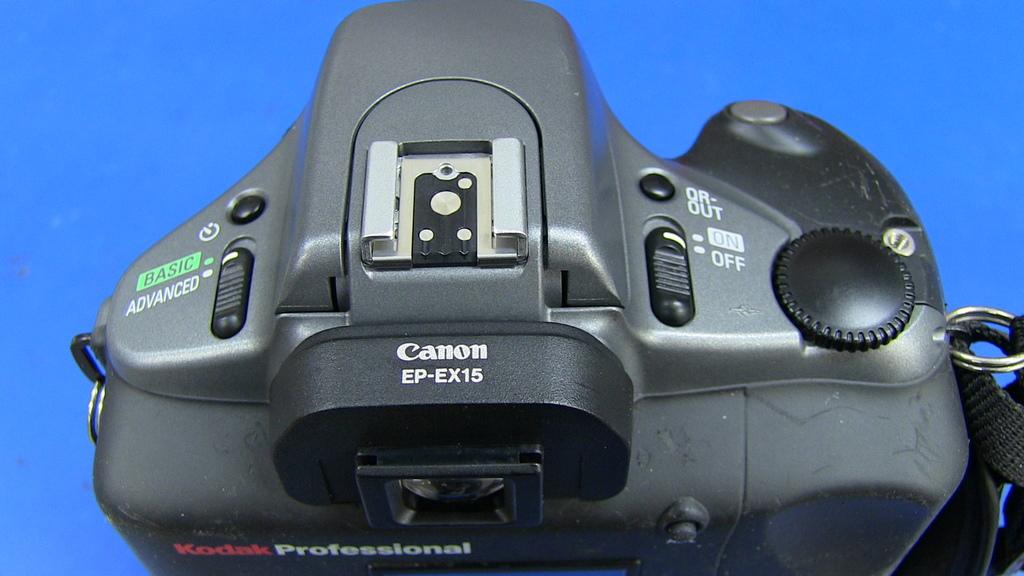What type of camera is it?
Keep it short and to the point. Canon. What level settings does the camera offer?
Provide a short and direct response. Basic advanced. 